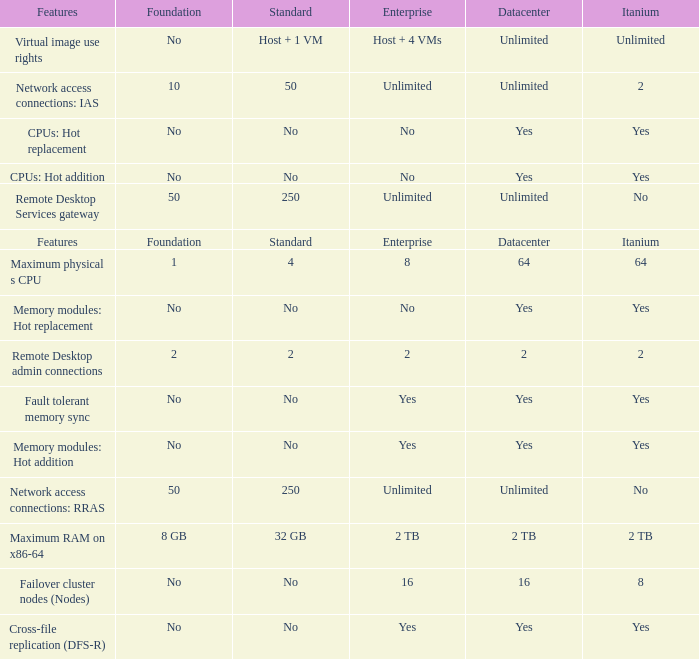What is the Datacenter for the Fault Tolerant Memory Sync Feature that has Yes for Itanium and No for Standard? Yes. 